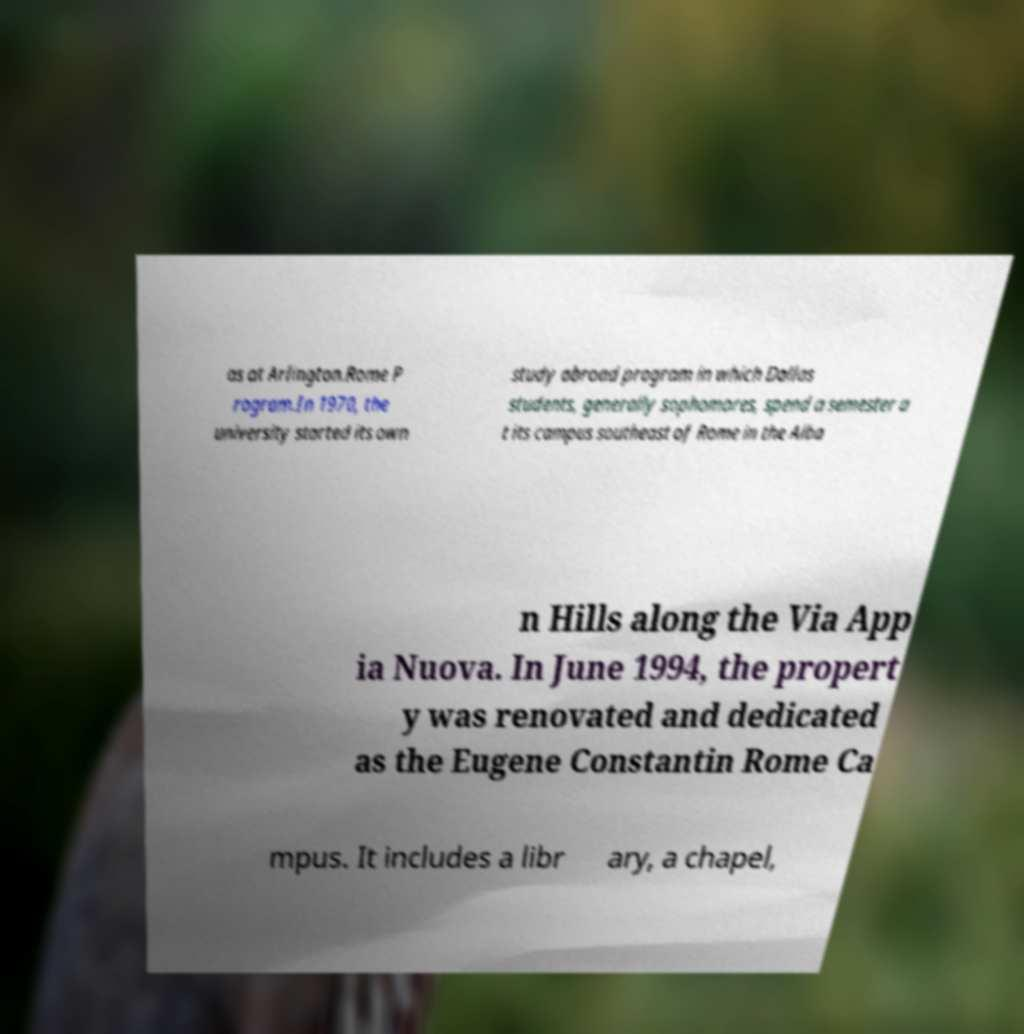There's text embedded in this image that I need extracted. Can you transcribe it verbatim? as at Arlington.Rome P rogram.In 1970, the university started its own study abroad program in which Dallas students, generally sophomores, spend a semester a t its campus southeast of Rome in the Alba n Hills along the Via App ia Nuova. In June 1994, the propert y was renovated and dedicated as the Eugene Constantin Rome Ca mpus. It includes a libr ary, a chapel, 